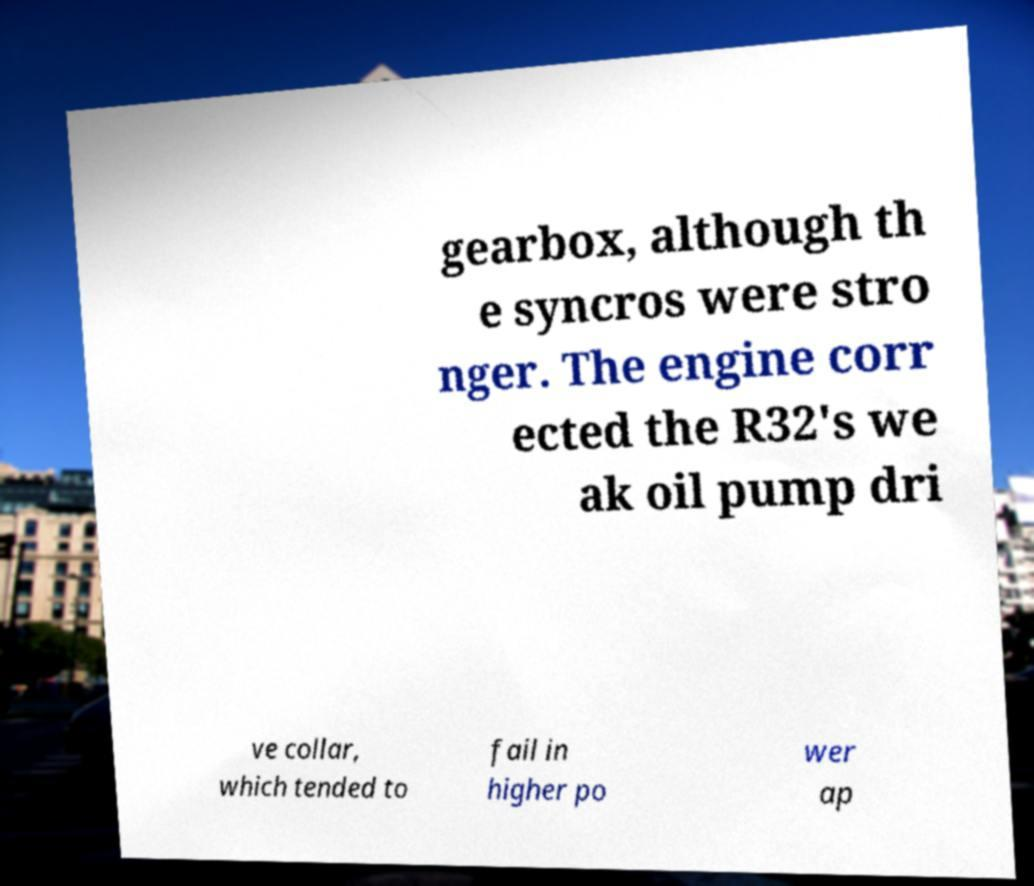Please identify and transcribe the text found in this image. gearbox, although th e syncros were stro nger. The engine corr ected the R32's we ak oil pump dri ve collar, which tended to fail in higher po wer ap 